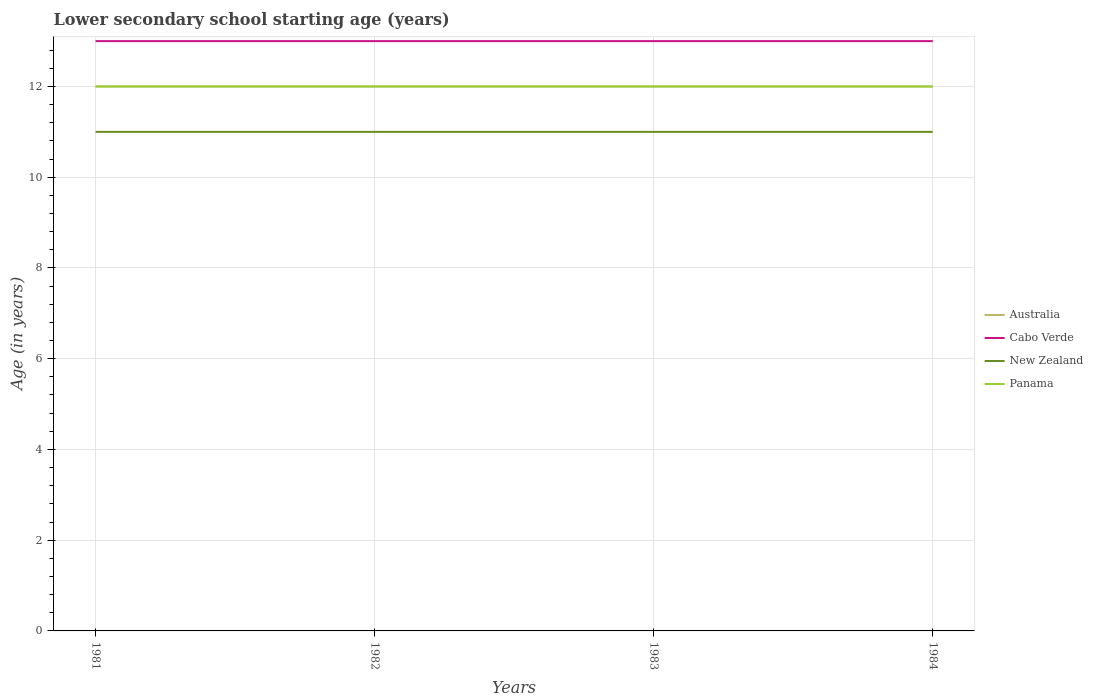Does the line corresponding to New Zealand intersect with the line corresponding to Cabo Verde?
Offer a very short reply. No. Is the number of lines equal to the number of legend labels?
Make the answer very short. Yes. Across all years, what is the maximum lower secondary school starting age of children in Cabo Verde?
Offer a terse response. 13. In which year was the lower secondary school starting age of children in Panama maximum?
Ensure brevity in your answer.  1981. Is the lower secondary school starting age of children in New Zealand strictly greater than the lower secondary school starting age of children in Cabo Verde over the years?
Ensure brevity in your answer.  Yes. How many lines are there?
Make the answer very short. 4. How many years are there in the graph?
Ensure brevity in your answer.  4. Are the values on the major ticks of Y-axis written in scientific E-notation?
Give a very brief answer. No. Does the graph contain any zero values?
Your answer should be very brief. No. How many legend labels are there?
Provide a succinct answer. 4. What is the title of the graph?
Make the answer very short. Lower secondary school starting age (years). What is the label or title of the X-axis?
Offer a very short reply. Years. What is the label or title of the Y-axis?
Your answer should be compact. Age (in years). What is the Age (in years) in Australia in 1981?
Your answer should be compact. 12. What is the Age (in years) in Cabo Verde in 1981?
Provide a succinct answer. 13. What is the Age (in years) of Panama in 1981?
Provide a succinct answer. 12. What is the Age (in years) in Australia in 1984?
Provide a short and direct response. 12. What is the Age (in years) in Panama in 1984?
Ensure brevity in your answer.  12. Across all years, what is the maximum Age (in years) in New Zealand?
Your answer should be compact. 11. Across all years, what is the maximum Age (in years) in Panama?
Make the answer very short. 12. Across all years, what is the minimum Age (in years) of Australia?
Keep it short and to the point. 12. Across all years, what is the minimum Age (in years) of New Zealand?
Your response must be concise. 11. Across all years, what is the minimum Age (in years) of Panama?
Your answer should be compact. 12. What is the total Age (in years) in Panama in the graph?
Your answer should be very brief. 48. What is the difference between the Age (in years) in Australia in 1981 and that in 1982?
Give a very brief answer. 0. What is the difference between the Age (in years) in Panama in 1981 and that in 1982?
Ensure brevity in your answer.  0. What is the difference between the Age (in years) of Australia in 1981 and that in 1983?
Make the answer very short. 0. What is the difference between the Age (in years) in Australia in 1981 and that in 1984?
Make the answer very short. 0. What is the difference between the Age (in years) in Cabo Verde in 1981 and that in 1984?
Provide a short and direct response. 0. What is the difference between the Age (in years) in Panama in 1981 and that in 1984?
Your answer should be compact. 0. What is the difference between the Age (in years) of Cabo Verde in 1982 and that in 1983?
Provide a short and direct response. 0. What is the difference between the Age (in years) of Panama in 1982 and that in 1983?
Give a very brief answer. 0. What is the difference between the Age (in years) of Australia in 1983 and that in 1984?
Make the answer very short. 0. What is the difference between the Age (in years) in Cabo Verde in 1983 and that in 1984?
Keep it short and to the point. 0. What is the difference between the Age (in years) of New Zealand in 1983 and that in 1984?
Offer a very short reply. 0. What is the difference between the Age (in years) of Australia in 1981 and the Age (in years) of New Zealand in 1982?
Provide a succinct answer. 1. What is the difference between the Age (in years) in New Zealand in 1981 and the Age (in years) in Panama in 1982?
Your answer should be very brief. -1. What is the difference between the Age (in years) of Cabo Verde in 1981 and the Age (in years) of Panama in 1983?
Your response must be concise. 1. What is the difference between the Age (in years) of Australia in 1981 and the Age (in years) of Cabo Verde in 1984?
Make the answer very short. -1. What is the difference between the Age (in years) in Australia in 1981 and the Age (in years) in New Zealand in 1984?
Keep it short and to the point. 1. What is the difference between the Age (in years) of Australia in 1981 and the Age (in years) of Panama in 1984?
Your answer should be very brief. 0. What is the difference between the Age (in years) in Cabo Verde in 1981 and the Age (in years) in New Zealand in 1984?
Ensure brevity in your answer.  2. What is the difference between the Age (in years) in Australia in 1982 and the Age (in years) in Cabo Verde in 1983?
Offer a very short reply. -1. What is the difference between the Age (in years) of Cabo Verde in 1982 and the Age (in years) of New Zealand in 1983?
Give a very brief answer. 2. What is the difference between the Age (in years) in Cabo Verde in 1982 and the Age (in years) in Panama in 1983?
Make the answer very short. 1. What is the difference between the Age (in years) in Australia in 1982 and the Age (in years) in New Zealand in 1984?
Provide a short and direct response. 1. What is the difference between the Age (in years) of Cabo Verde in 1982 and the Age (in years) of New Zealand in 1984?
Make the answer very short. 2. What is the difference between the Age (in years) of New Zealand in 1982 and the Age (in years) of Panama in 1984?
Make the answer very short. -1. What is the difference between the Age (in years) of Australia in 1983 and the Age (in years) of Cabo Verde in 1984?
Give a very brief answer. -1. What is the difference between the Age (in years) of Australia in 1983 and the Age (in years) of Panama in 1984?
Your answer should be compact. 0. What is the difference between the Age (in years) of Cabo Verde in 1983 and the Age (in years) of Panama in 1984?
Ensure brevity in your answer.  1. What is the difference between the Age (in years) in New Zealand in 1983 and the Age (in years) in Panama in 1984?
Offer a very short reply. -1. What is the average Age (in years) in Australia per year?
Your response must be concise. 12. What is the average Age (in years) in Cabo Verde per year?
Provide a short and direct response. 13. What is the average Age (in years) in New Zealand per year?
Keep it short and to the point. 11. In the year 1981, what is the difference between the Age (in years) in Australia and Age (in years) in Panama?
Give a very brief answer. 0. In the year 1981, what is the difference between the Age (in years) of Cabo Verde and Age (in years) of New Zealand?
Your answer should be compact. 2. In the year 1981, what is the difference between the Age (in years) of New Zealand and Age (in years) of Panama?
Offer a very short reply. -1. In the year 1982, what is the difference between the Age (in years) of Cabo Verde and Age (in years) of New Zealand?
Keep it short and to the point. 2. In the year 1982, what is the difference between the Age (in years) of Cabo Verde and Age (in years) of Panama?
Ensure brevity in your answer.  1. In the year 1983, what is the difference between the Age (in years) in Australia and Age (in years) in New Zealand?
Give a very brief answer. 1. In the year 1983, what is the difference between the Age (in years) of Cabo Verde and Age (in years) of Panama?
Your answer should be very brief. 1. In the year 1983, what is the difference between the Age (in years) of New Zealand and Age (in years) of Panama?
Offer a very short reply. -1. In the year 1984, what is the difference between the Age (in years) of Australia and Age (in years) of New Zealand?
Offer a very short reply. 1. In the year 1984, what is the difference between the Age (in years) in Cabo Verde and Age (in years) in New Zealand?
Your answer should be very brief. 2. What is the ratio of the Age (in years) of Australia in 1981 to that in 1982?
Offer a very short reply. 1. What is the ratio of the Age (in years) in New Zealand in 1981 to that in 1982?
Keep it short and to the point. 1. What is the ratio of the Age (in years) in Panama in 1981 to that in 1982?
Your answer should be compact. 1. What is the ratio of the Age (in years) in Australia in 1981 to that in 1983?
Your answer should be very brief. 1. What is the ratio of the Age (in years) in Australia in 1981 to that in 1984?
Your answer should be very brief. 1. What is the ratio of the Age (in years) of Australia in 1982 to that in 1983?
Keep it short and to the point. 1. What is the ratio of the Age (in years) in New Zealand in 1982 to that in 1983?
Your response must be concise. 1. What is the ratio of the Age (in years) of New Zealand in 1982 to that in 1984?
Make the answer very short. 1. What is the ratio of the Age (in years) of Panama in 1982 to that in 1984?
Give a very brief answer. 1. What is the ratio of the Age (in years) in Australia in 1983 to that in 1984?
Your answer should be compact. 1. What is the ratio of the Age (in years) in Cabo Verde in 1983 to that in 1984?
Provide a short and direct response. 1. What is the difference between the highest and the lowest Age (in years) in Panama?
Your answer should be very brief. 0. 